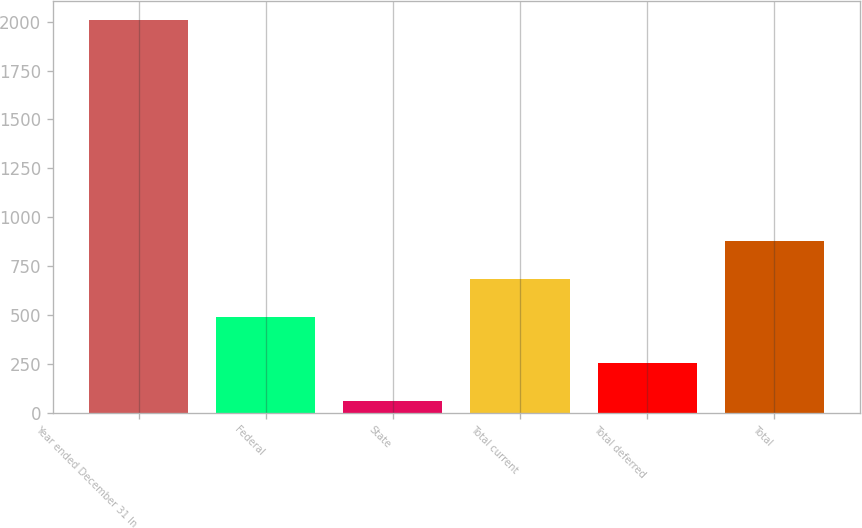Convert chart. <chart><loc_0><loc_0><loc_500><loc_500><bar_chart><fcel>Year ended December 31 In<fcel>Federal<fcel>State<fcel>Total current<fcel>Total deferred<fcel>Total<nl><fcel>2007<fcel>491<fcel>58<fcel>685.9<fcel>252.9<fcel>880.8<nl></chart> 